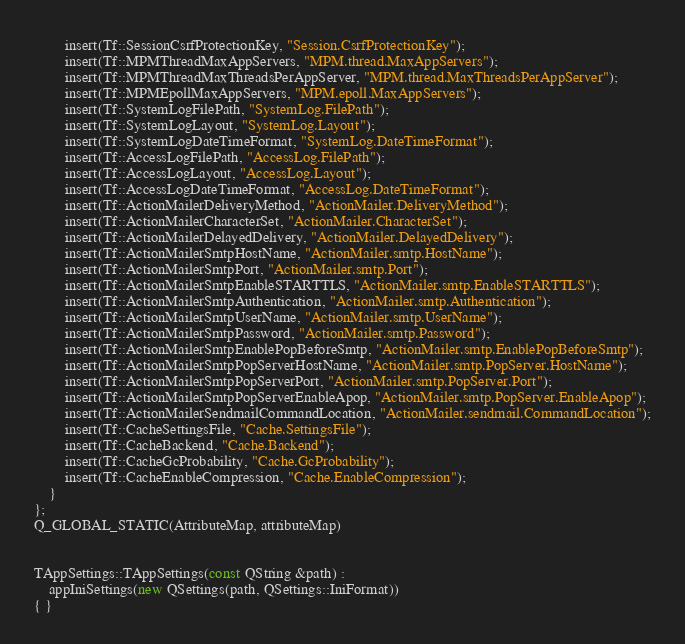<code> <loc_0><loc_0><loc_500><loc_500><_C++_>        insert(Tf::SessionCsrfProtectionKey, "Session.CsrfProtectionKey");
        insert(Tf::MPMThreadMaxAppServers, "MPM.thread.MaxAppServers");
        insert(Tf::MPMThreadMaxThreadsPerAppServer, "MPM.thread.MaxThreadsPerAppServer");
        insert(Tf::MPMEpollMaxAppServers, "MPM.epoll.MaxAppServers");
        insert(Tf::SystemLogFilePath, "SystemLog.FilePath");
        insert(Tf::SystemLogLayout, "SystemLog.Layout");
        insert(Tf::SystemLogDateTimeFormat, "SystemLog.DateTimeFormat");
        insert(Tf::AccessLogFilePath, "AccessLog.FilePath");
        insert(Tf::AccessLogLayout, "AccessLog.Layout");
        insert(Tf::AccessLogDateTimeFormat, "AccessLog.DateTimeFormat");
        insert(Tf::ActionMailerDeliveryMethod, "ActionMailer.DeliveryMethod");
        insert(Tf::ActionMailerCharacterSet, "ActionMailer.CharacterSet");
        insert(Tf::ActionMailerDelayedDelivery, "ActionMailer.DelayedDelivery");
        insert(Tf::ActionMailerSmtpHostName, "ActionMailer.smtp.HostName");
        insert(Tf::ActionMailerSmtpPort, "ActionMailer.smtp.Port");
        insert(Tf::ActionMailerSmtpEnableSTARTTLS, "ActionMailer.smtp.EnableSTARTTLS");
        insert(Tf::ActionMailerSmtpAuthentication, "ActionMailer.smtp.Authentication");
        insert(Tf::ActionMailerSmtpUserName, "ActionMailer.smtp.UserName");
        insert(Tf::ActionMailerSmtpPassword, "ActionMailer.smtp.Password");
        insert(Tf::ActionMailerSmtpEnablePopBeforeSmtp, "ActionMailer.smtp.EnablePopBeforeSmtp");
        insert(Tf::ActionMailerSmtpPopServerHostName, "ActionMailer.smtp.PopServer.HostName");
        insert(Tf::ActionMailerSmtpPopServerPort, "ActionMailer.smtp.PopServer.Port");
        insert(Tf::ActionMailerSmtpPopServerEnableApop, "ActionMailer.smtp.PopServer.EnableApop");
        insert(Tf::ActionMailerSendmailCommandLocation, "ActionMailer.sendmail.CommandLocation");
        insert(Tf::CacheSettingsFile, "Cache.SettingsFile");
        insert(Tf::CacheBackend, "Cache.Backend");
        insert(Tf::CacheGcProbability, "Cache.GcProbability");
        insert(Tf::CacheEnableCompression, "Cache.EnableCompression");
    }
};
Q_GLOBAL_STATIC(AttributeMap, attributeMap)


TAppSettings::TAppSettings(const QString &path) :
    appIniSettings(new QSettings(path, QSettings::IniFormat))
{ }

</code> 